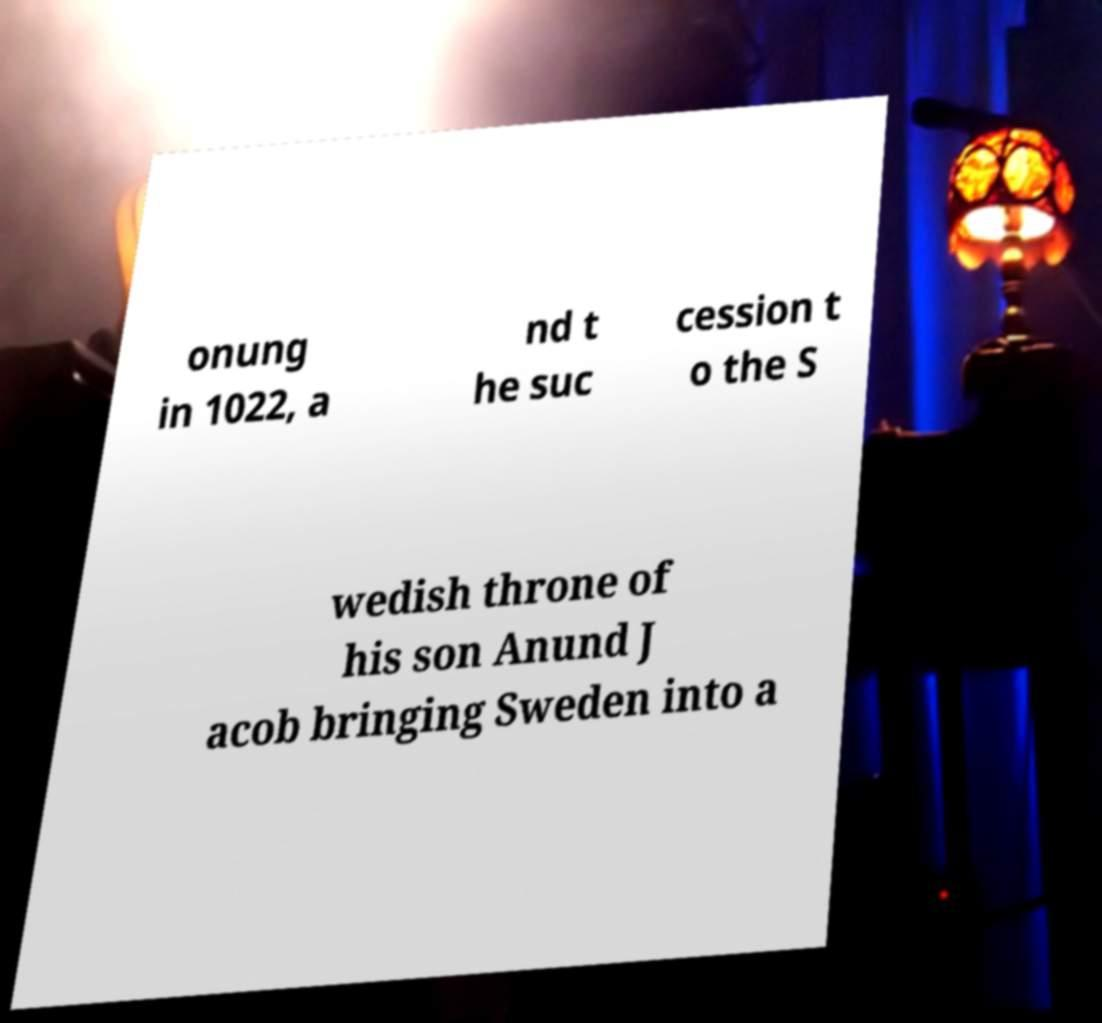Please read and relay the text visible in this image. What does it say? onung in 1022, a nd t he suc cession t o the S wedish throne of his son Anund J acob bringing Sweden into a 